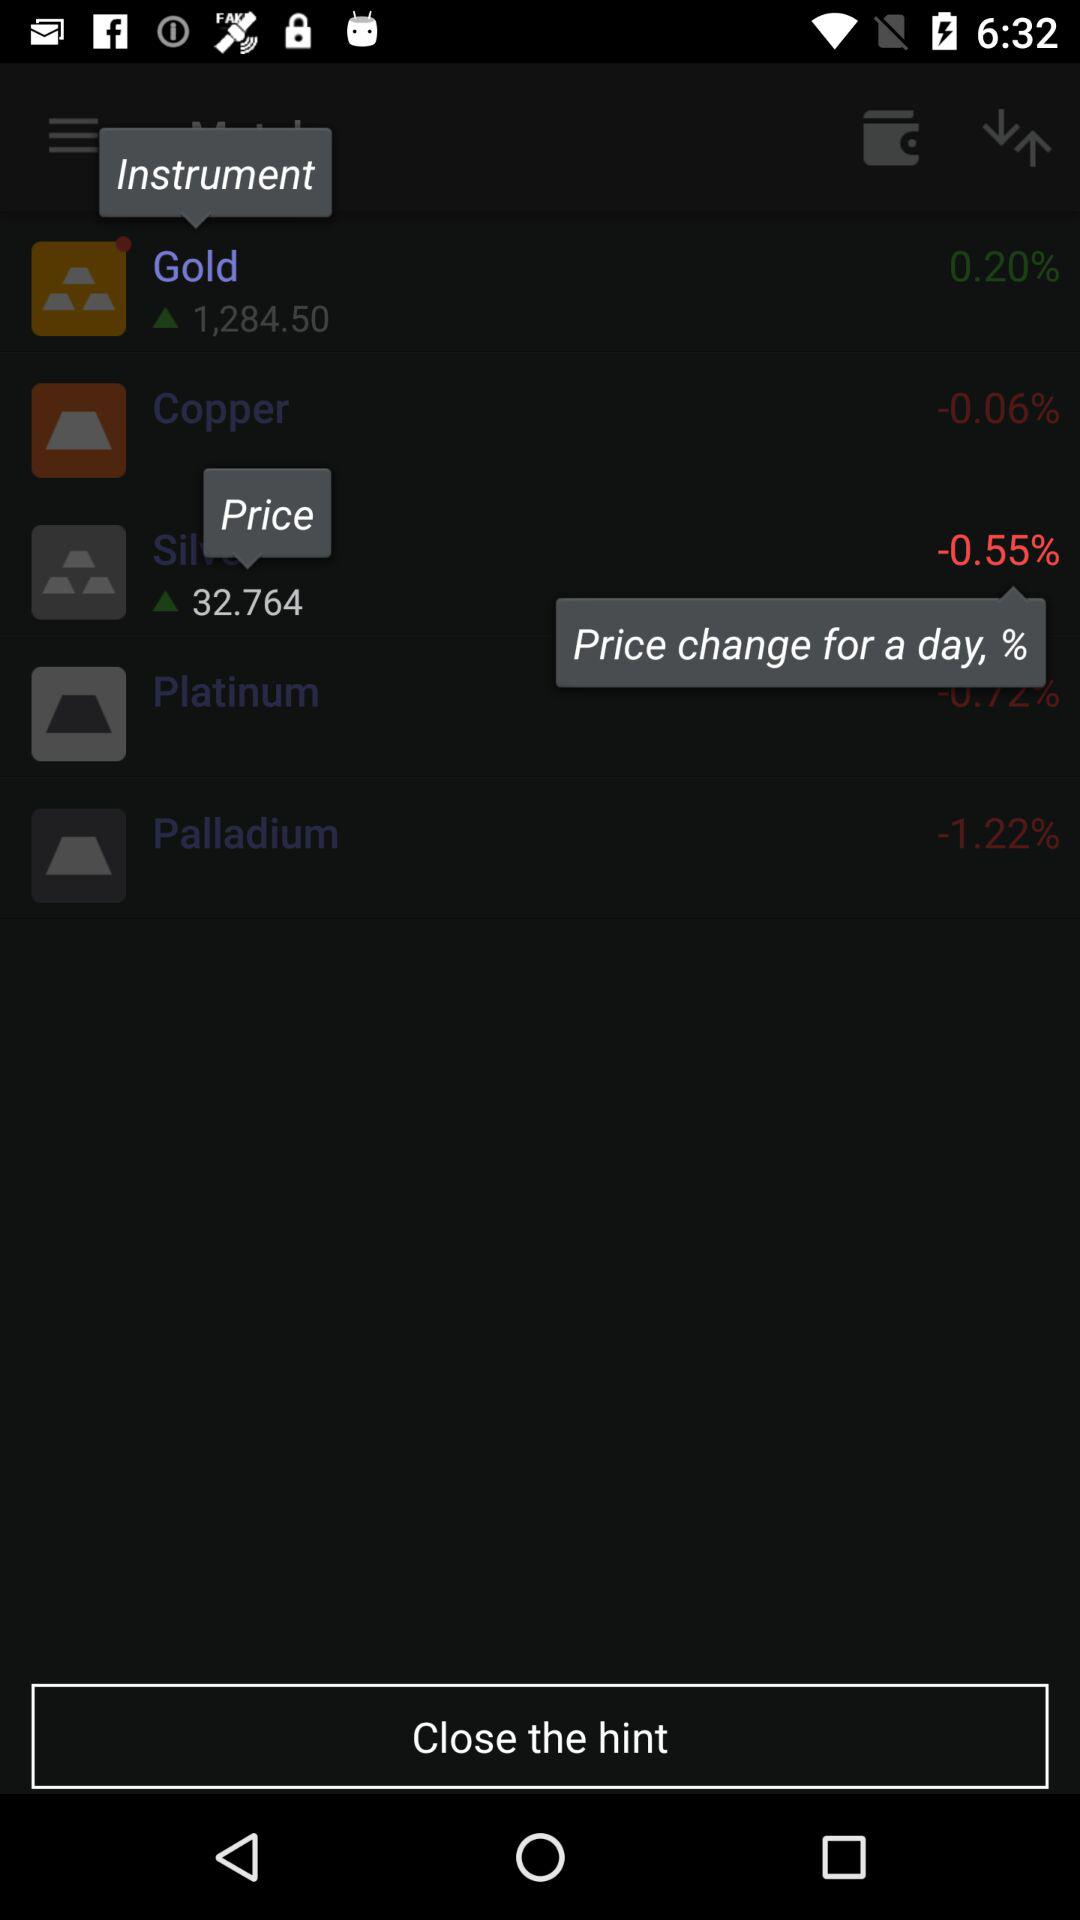What is the price of "Gold"? The price of "Gold" is 1,284.50. 